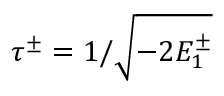<formula> <loc_0><loc_0><loc_500><loc_500>\tau ^ { \pm } = 1 / \sqrt { - 2 E _ { 1 } ^ { \pm } }</formula> 